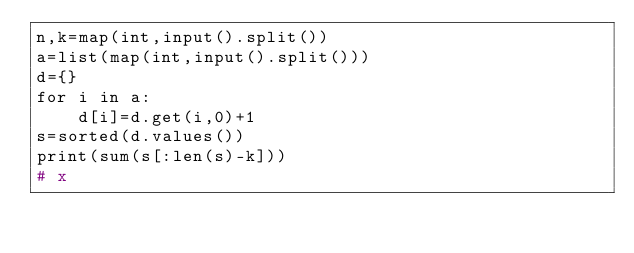<code> <loc_0><loc_0><loc_500><loc_500><_Python_>n,k=map(int,input().split())
a=list(map(int,input().split()))
d={}
for i in a:
	d[i]=d.get(i,0)+1
s=sorted(d.values())
print(sum(s[:len(s)-k]))
# x</code> 